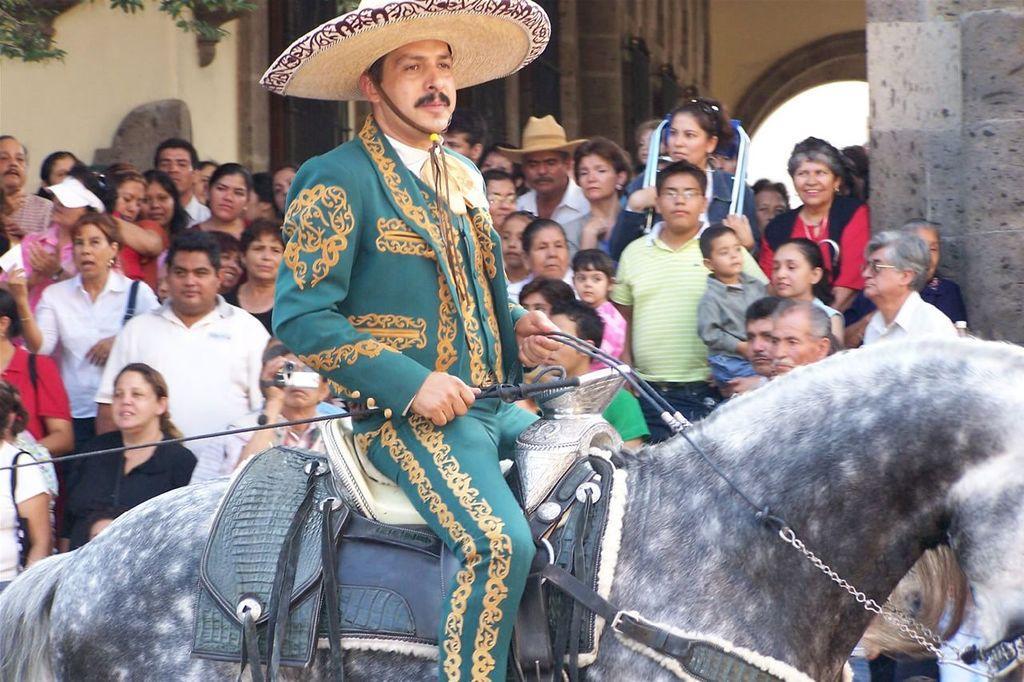Could you give a brief overview of what you see in this image? In this picture we can see a man is sitting on a horse, here is the paddle on it and he is catching a rope in his hand, here are group of people standing and looking, and here is the wall and beside there are some trees. 